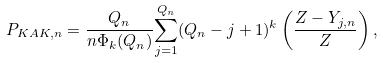Convert formula to latex. <formula><loc_0><loc_0><loc_500><loc_500>P _ { K A K , n } = \frac { Q _ { n } } { n \Phi _ { k } ( Q _ { n } ) } \overset { Q _ { n } } { \underset { j = 1 } { \sum } } ( Q _ { n } - j + 1 ) ^ { k } \left ( \frac { Z - Y _ { j , n } } { Z } \right ) ,</formula> 